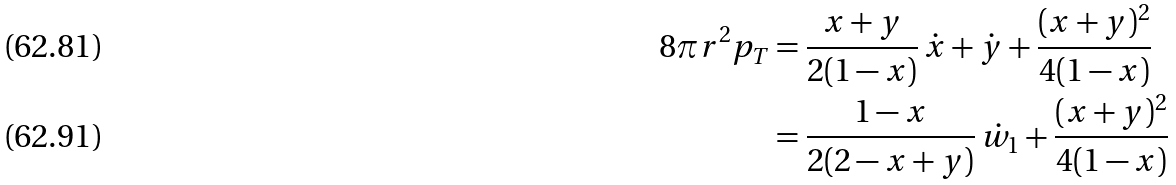<formula> <loc_0><loc_0><loc_500><loc_500>8 \pi r ^ { 2 } p _ { T } & = \frac { x + y } { 2 ( 1 - x ) } \, \dot { x } + \dot { y } + \frac { ( x + y ) ^ { 2 } } { 4 ( 1 - x ) } \\ & = \frac { 1 - x } { 2 ( 2 - x + y ) } \, \dot { w } _ { 1 } + \frac { ( x + y ) ^ { 2 } } { 4 ( 1 - x ) }</formula> 